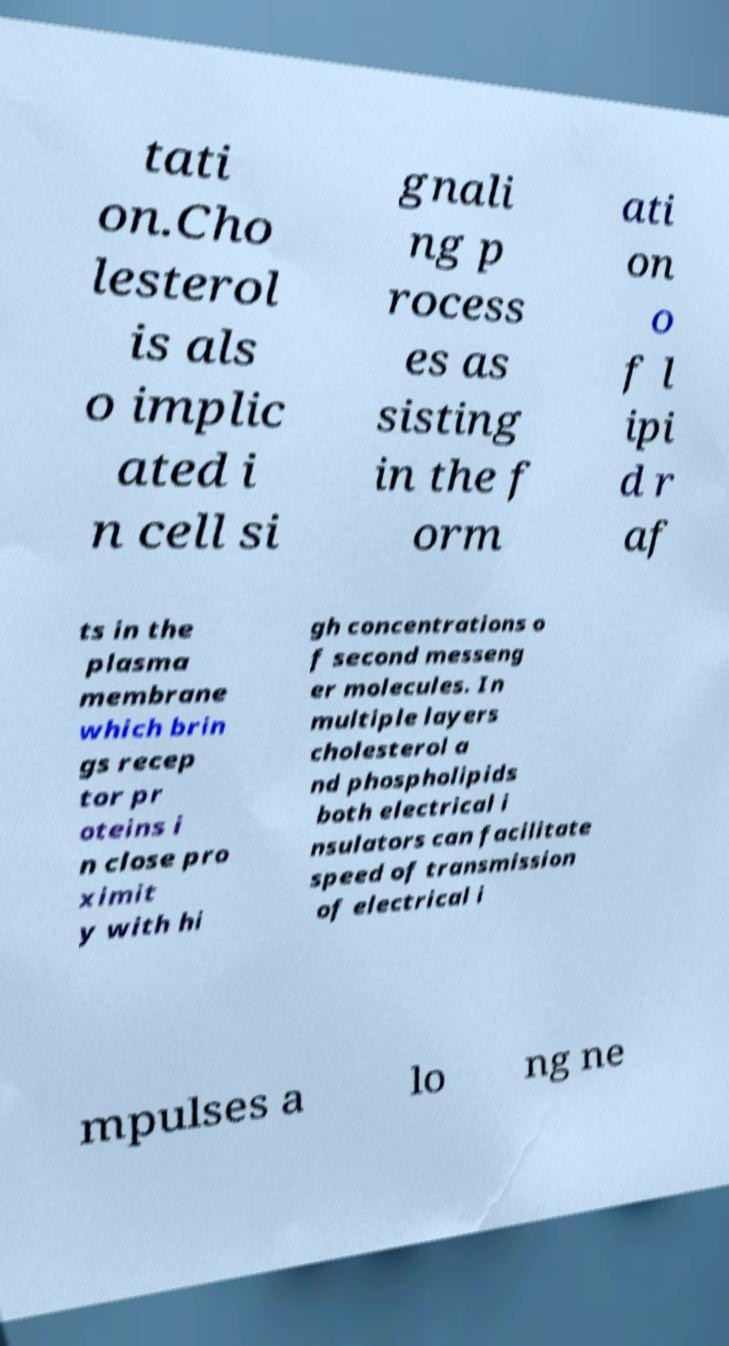Could you extract and type out the text from this image? tati on.Cho lesterol is als o implic ated i n cell si gnali ng p rocess es as sisting in the f orm ati on o f l ipi d r af ts in the plasma membrane which brin gs recep tor pr oteins i n close pro ximit y with hi gh concentrations o f second messeng er molecules. In multiple layers cholesterol a nd phospholipids both electrical i nsulators can facilitate speed of transmission of electrical i mpulses a lo ng ne 